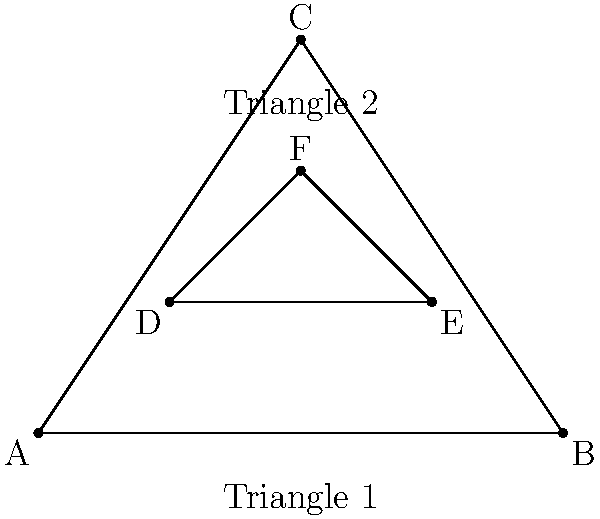In a VR environment, two triangular objects are represented by Triangle 1 (ABC) and Triangle 2 (DEF). What is the most efficient method to determine if these triangles intersect for real-time collision detection, and what is the time complexity of this method? To efficiently determine if two triangles intersect in a VR environment for real-time collision detection, we can use the Separating Axis Theorem (SAT). Here's a step-by-step explanation:

1. The SAT states that two convex polygons do not intersect if there exists a line (separating axis) onto which the projections of the polygons do not overlap.

2. For triangles, we need to test at most 6 potential separating axes:
   a. The normal of Triangle 1
   b. The normal of Triangle 2
   c. The cross product of each edge from Triangle 1 with each edge from Triangle 2 (3 × 1 = 3 axes)

3. To test each axis:
   a. Project all vertices of both triangles onto the axis
   b. Check if the projections overlap

4. If all 6 axes fail to separate the triangles, they intersect.

5. The time complexity of this method is O(1) because:
   a. The number of vertices and edges is constant (3 for each triangle)
   b. The number of axes to test is also constant (6)

This method is efficient for real-time collision detection in VR environments because:
1. It has constant time complexity, regardless of triangle size or position
2. It can be easily parallelized for GPU acceleration
3. It works well with hierarchical bounding volume structures for complex scenes
Answer: Separating Axis Theorem (SAT) with O(1) time complexity 